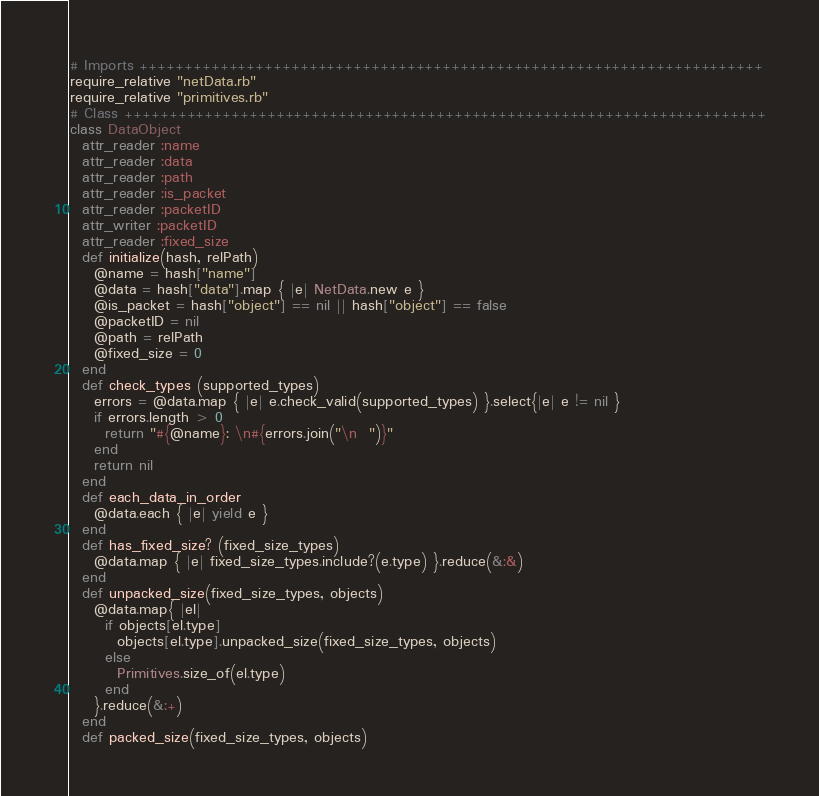Convert code to text. <code><loc_0><loc_0><loc_500><loc_500><_Ruby_># Imports ++++++++++++++++++++++++++++++++++++++++++++++++++++++++++++++++++++++
require_relative "netData.rb"
require_relative "primitives.rb"
# Class ++++++++++++++++++++++++++++++++++++++++++++++++++++++++++++++++++++++++
class DataObject
  attr_reader :name
  attr_reader :data
  attr_reader :path
  attr_reader :is_packet
  attr_reader :packetID
  attr_writer :packetID
  attr_reader :fixed_size
  def initialize(hash, relPath)
    @name = hash["name"]
    @data = hash["data"].map { |e| NetData.new e }
    @is_packet = hash["object"] == nil || hash["object"] == false
    @packetID = nil
    @path = relPath
    @fixed_size = 0
  end
  def check_types (supported_types)
    errors = @data.map { |e| e.check_valid(supported_types) }.select{|e| e != nil }
    if errors.length > 0
      return "#{@name}: \n#{errors.join("\n  ")}"
    end
    return nil
  end
  def each_data_in_order
    @data.each { |e| yield e }
  end
  def has_fixed_size? (fixed_size_types)
    @data.map { |e| fixed_size_types.include?(e.type) }.reduce(&:&)
  end
  def unpacked_size(fixed_size_types, objects)
    @data.map{ |el|
      if objects[el.type]
        objects[el.type].unpacked_size(fixed_size_types, objects)
      else
        Primitives.size_of(el.type)
      end
    }.reduce(&:+)
  end
  def packed_size(fixed_size_types, objects)</code> 